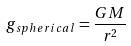<formula> <loc_0><loc_0><loc_500><loc_500>g _ { s p h e r i c a l } = \frac { G M } { r ^ { 2 } }</formula> 